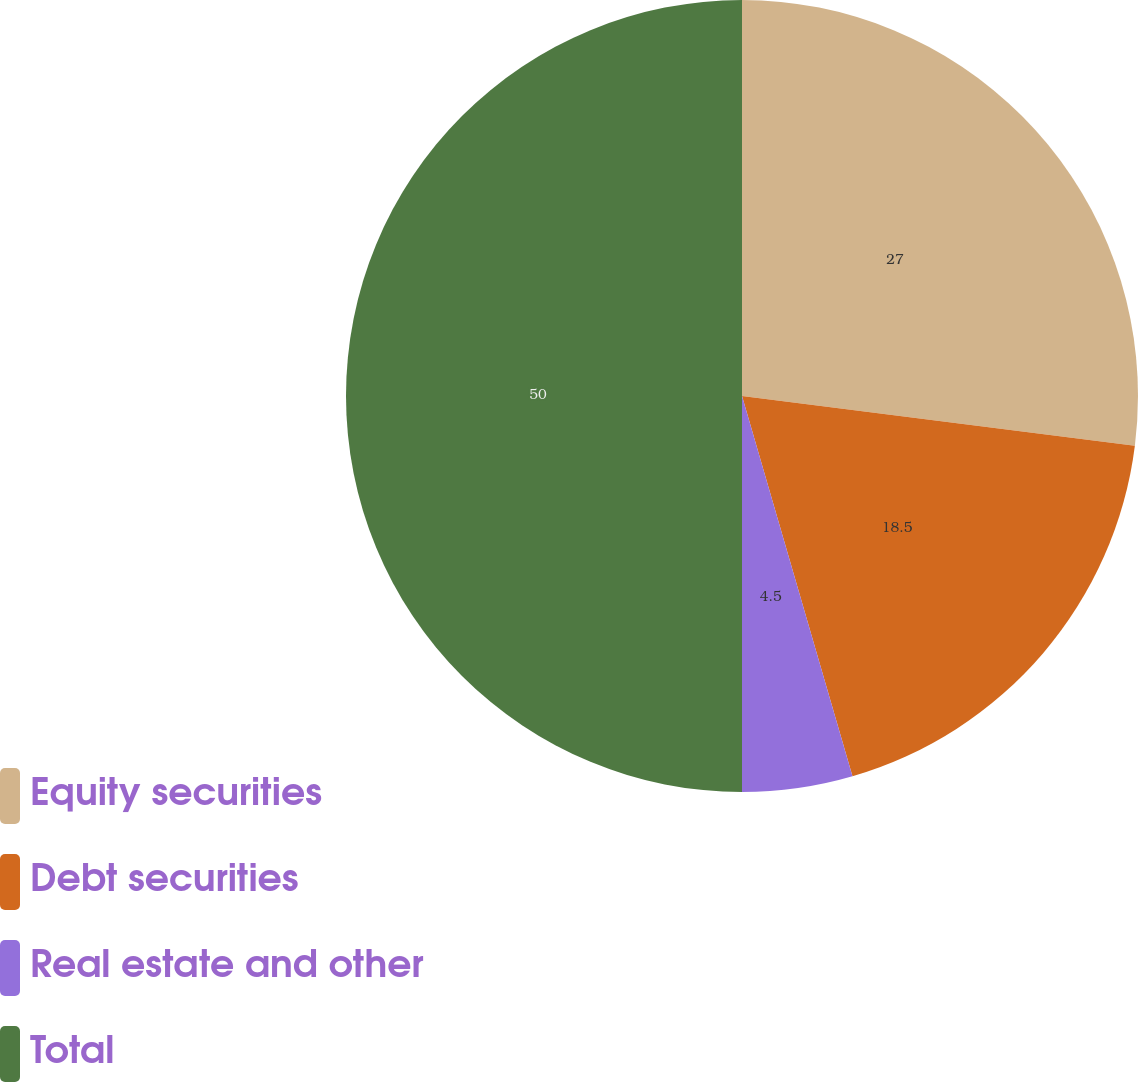<chart> <loc_0><loc_0><loc_500><loc_500><pie_chart><fcel>Equity securities<fcel>Debt securities<fcel>Real estate and other<fcel>Total<nl><fcel>27.0%<fcel>18.5%<fcel>4.5%<fcel>50.0%<nl></chart> 